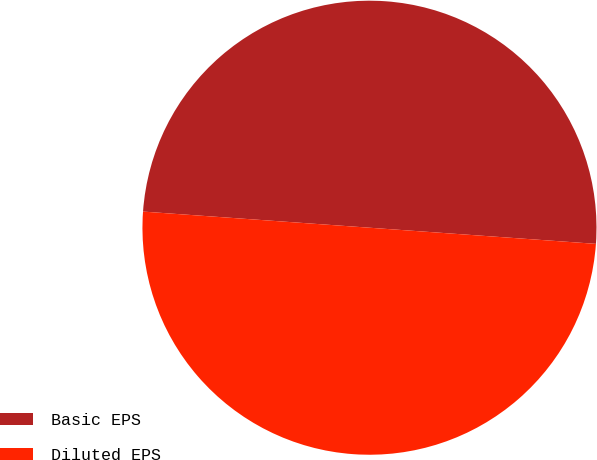Convert chart. <chart><loc_0><loc_0><loc_500><loc_500><pie_chart><fcel>Basic EPS<fcel>Diluted EPS<nl><fcel>50.0%<fcel>50.0%<nl></chart> 